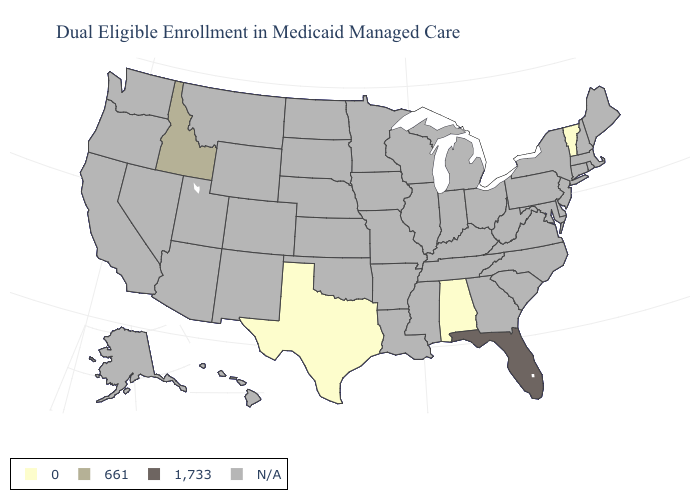Which states have the highest value in the USA?
Write a very short answer. Florida. What is the value of Illinois?
Be succinct. N/A. Does Florida have the lowest value in the USA?
Be succinct. No. Name the states that have a value in the range 1,733?
Quick response, please. Florida. What is the value of Hawaii?
Short answer required. N/A. Name the states that have a value in the range N/A?
Quick response, please. Alaska, Arizona, Arkansas, California, Colorado, Connecticut, Delaware, Georgia, Hawaii, Illinois, Indiana, Iowa, Kansas, Kentucky, Louisiana, Maine, Maryland, Massachusetts, Michigan, Minnesota, Mississippi, Missouri, Montana, Nebraska, Nevada, New Hampshire, New Jersey, New Mexico, New York, North Carolina, North Dakota, Ohio, Oklahoma, Oregon, Pennsylvania, Rhode Island, South Carolina, South Dakota, Tennessee, Utah, Virginia, Washington, West Virginia, Wisconsin, Wyoming. Name the states that have a value in the range 0?
Give a very brief answer. Alabama, Texas, Vermont. Among the states that border New York , which have the lowest value?
Quick response, please. Vermont. Name the states that have a value in the range 1,733?
Concise answer only. Florida. Which states have the lowest value in the USA?
Short answer required. Alabama, Texas, Vermont. 